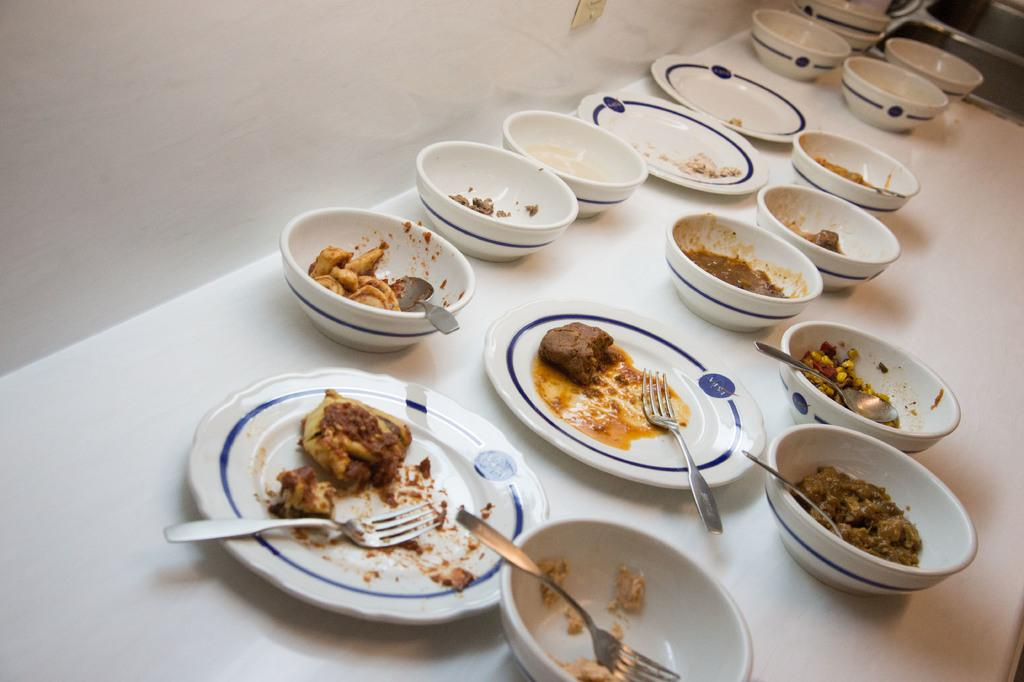What type of food items can be seen in the image? There are bowls and plates of food items in the image. What utensils are visible in the image? Forks and spoons are visible in the image. How many plates are visible in the image, and what is their status? There is one empty plate visible in the image. What can be seen on the surface in the image? The surface is visible in the image, and it appears to be a table or countertop. What is present in the background of the image? There is a wall visible in the image. What type of mint can be seen growing on the wall in the image? There is no mint visible in the image, and the wall does not appear to have any plants growing on it. 